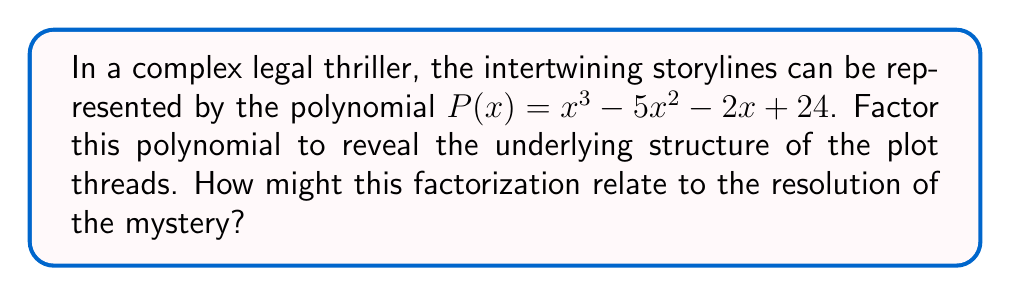Show me your answer to this math problem. To factor the polynomial $P(x) = x^3 - 5x^2 - 2x + 24$, we'll follow these steps:

1) First, let's check if there are any rational roots using the rational root theorem. The possible rational roots are the factors of the constant term: ±1, ±2, ±3, ±4, ±6, ±8, ±12, ±24.

2) Testing these values, we find that x = 4 is a root of the polynomial.

3) We can factor out (x - 4):
   $P(x) = (x - 4)(x^2 + ax + b)$

4) To find a and b, we can use polynomial long division or compare coefficients:
   $x^3 - 5x^2 - 2x + 24 = (x - 4)(x^2 + ax + b)$
   $x^3 - 5x^2 - 2x + 24 = x^3 + ax^2 + bx - 4x^2 - 4ax - 4b$

5) Comparing coefficients:
   $-5 = a - 4$
   $-2 = b - 4a$
   $24 = -4b$

6) Solving these equations:
   $a = -1$
   $b = -6$

7) Therefore, our factored polynomial is:
   $P(x) = (x - 4)(x^2 - x - 6)$

8) The quadratic factor can be further factored:
   $x^2 - x - 6 = (x - 3)(x + 2)$

9) Thus, the final factorization is:
   $P(x) = (x - 4)(x - 3)(x + 2)$

In the context of a legal thriller, this factorization could represent three key plot threads (x - 4), (x - 3), and (x + 2) that, when resolved, lead to the overall resolution of the mystery. The fact that they multiply to form the original polynomial suggests how these threads are intricately connected in the story.
Answer: $(x - 4)(x - 3)(x + 2)$ 